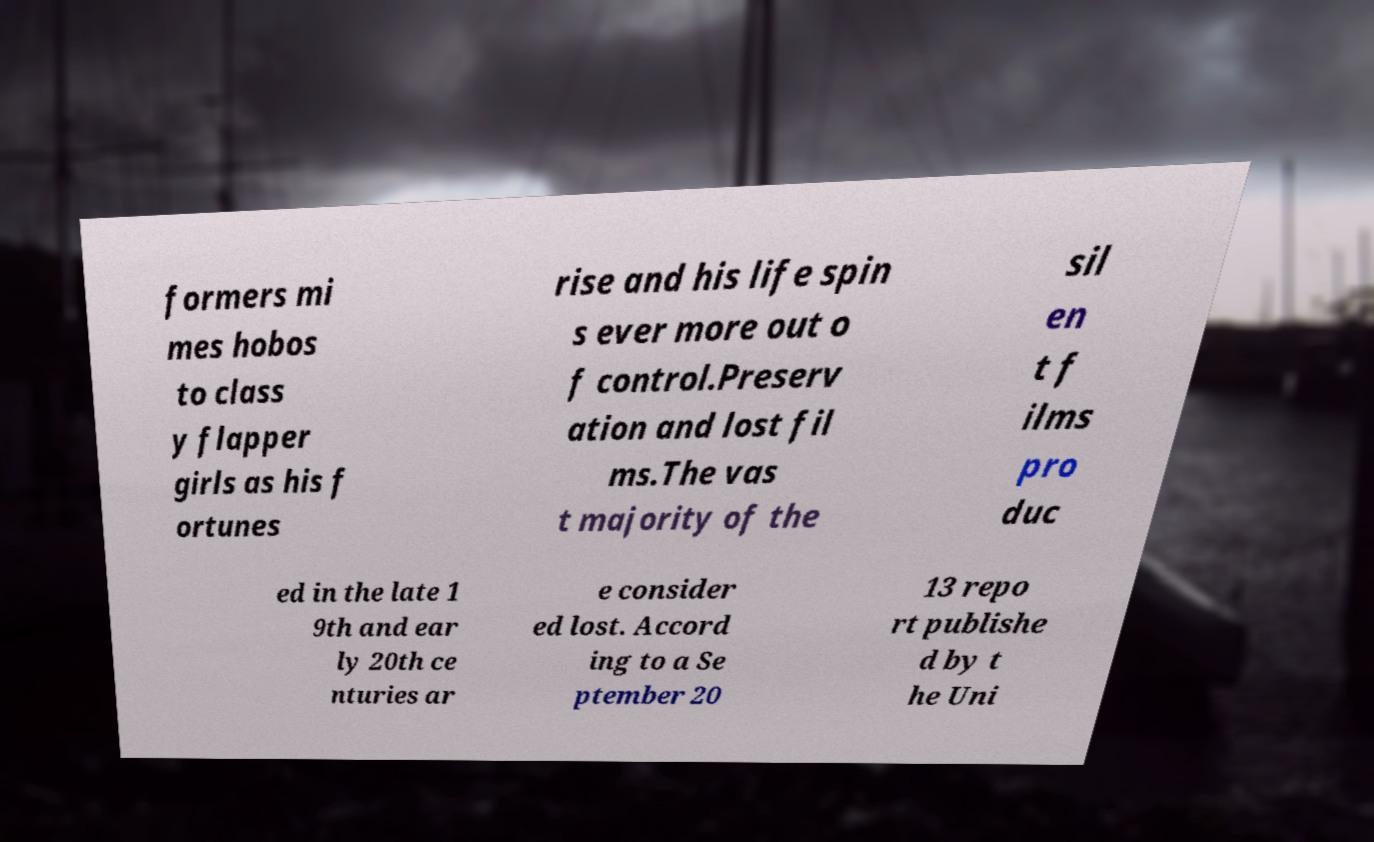Please read and relay the text visible in this image. What does it say? formers mi mes hobos to class y flapper girls as his f ortunes rise and his life spin s ever more out o f control.Preserv ation and lost fil ms.The vas t majority of the sil en t f ilms pro duc ed in the late 1 9th and ear ly 20th ce nturies ar e consider ed lost. Accord ing to a Se ptember 20 13 repo rt publishe d by t he Uni 